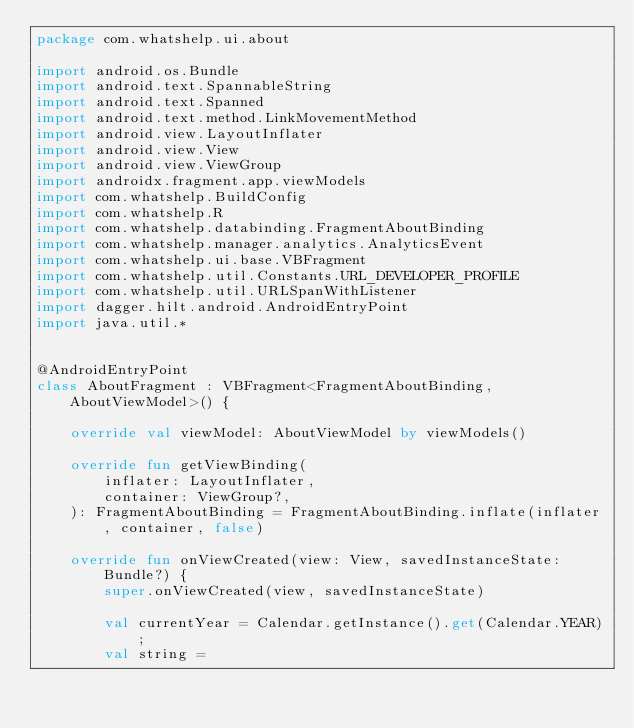Convert code to text. <code><loc_0><loc_0><loc_500><loc_500><_Kotlin_>package com.whatshelp.ui.about

import android.os.Bundle
import android.text.SpannableString
import android.text.Spanned
import android.text.method.LinkMovementMethod
import android.view.LayoutInflater
import android.view.View
import android.view.ViewGroup
import androidx.fragment.app.viewModels
import com.whatshelp.BuildConfig
import com.whatshelp.R
import com.whatshelp.databinding.FragmentAboutBinding
import com.whatshelp.manager.analytics.AnalyticsEvent
import com.whatshelp.ui.base.VBFragment
import com.whatshelp.util.Constants.URL_DEVELOPER_PROFILE
import com.whatshelp.util.URLSpanWithListener
import dagger.hilt.android.AndroidEntryPoint
import java.util.*


@AndroidEntryPoint
class AboutFragment : VBFragment<FragmentAboutBinding, AboutViewModel>() {

    override val viewModel: AboutViewModel by viewModels()

    override fun getViewBinding(
        inflater: LayoutInflater,
        container: ViewGroup?,
    ): FragmentAboutBinding = FragmentAboutBinding.inflate(inflater, container, false)

    override fun onViewCreated(view: View, savedInstanceState: Bundle?) {
        super.onViewCreated(view, savedInstanceState)

        val currentYear = Calendar.getInstance().get(Calendar.YEAR);
        val string =</code> 